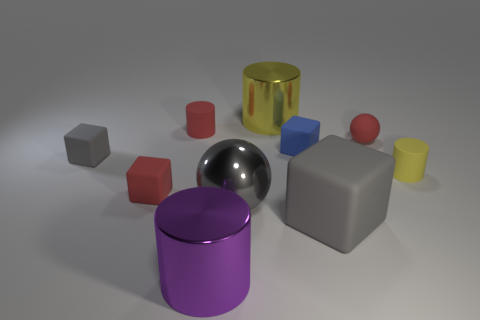Is the color of the big block the same as the small ball?
Keep it short and to the point. No. Are there more gray objects behind the tiny rubber ball than red rubber objects that are in front of the tiny blue object?
Provide a short and direct response. No. What color is the matte cylinder on the right side of the blue block?
Give a very brief answer. Yellow. Are there any purple objects that have the same shape as the small blue thing?
Ensure brevity in your answer.  No. How many gray things are either big shiny balls or big shiny cylinders?
Provide a succinct answer. 1. Is there a blue matte cube of the same size as the purple cylinder?
Give a very brief answer. No. What number of red rubber blocks are there?
Offer a terse response. 1. How many small objects are either yellow cylinders or shiny balls?
Give a very brief answer. 1. What is the color of the big shiny cylinder that is behind the tiny cylinder right of the big shiny cylinder that is to the right of the big purple metallic cylinder?
Your response must be concise. Yellow. What number of other things are the same color as the large metal sphere?
Your response must be concise. 2. 